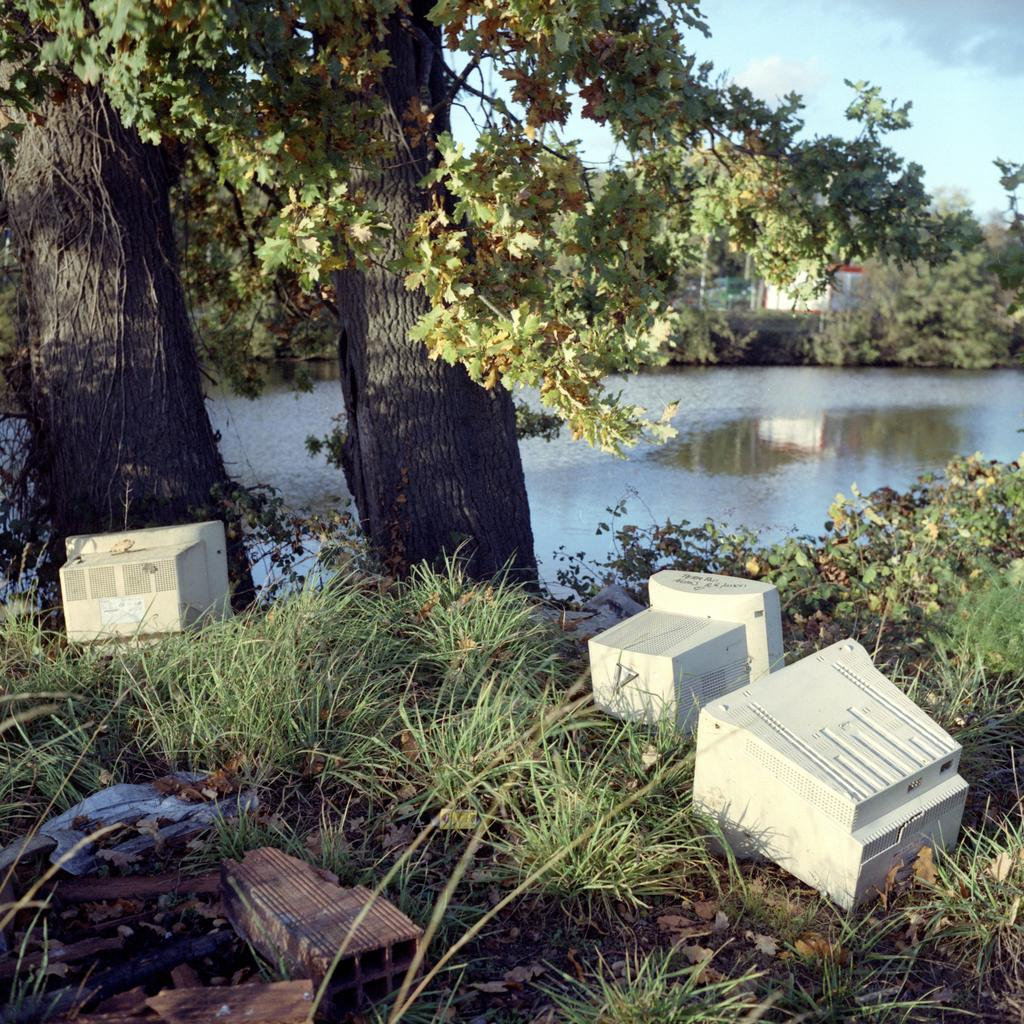What is located on the ground in the image? There are systems on the ground in the image. What type of vegetation can be seen in the image? There are trees and plants in the image. What natural element is visible in the image? Water is visible in the image. What part of the natural environment is visible in the image? The sky is visible in the image. Can you see your uncle wearing a ring in the image? There is no person, including an uncle, present in the image. What type of sack is being used to carry the plants in the image? There is no sack visible in the image; the plants are not being carried. 